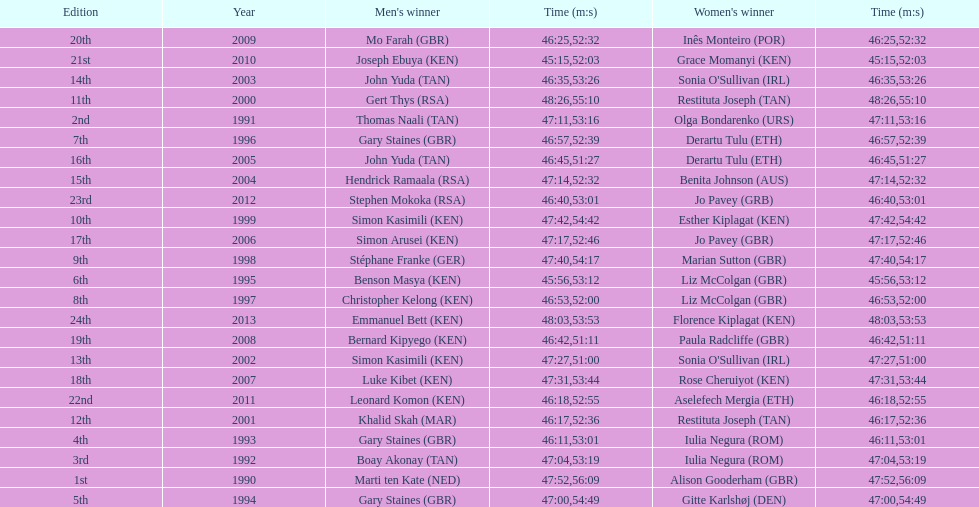How many minutes or seconds did sonia o'sullivan need to complete the race in 2003? 53:26. 